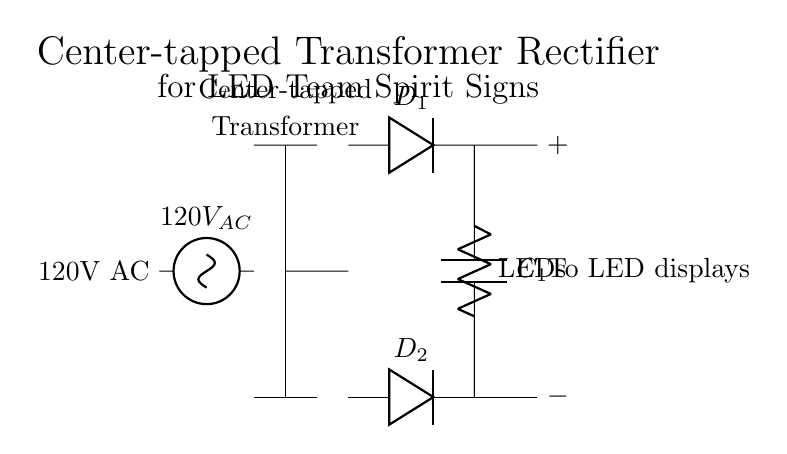What is the input voltage to the circuit? The input voltage to the circuit is labeled as 120V AC, which is a common voltage for household circuits.
Answer: 120V AC What is the purpose of the smoothing capacitor? The smoothing capacitor is used to reduce the ripple in the output voltage, providing a more stable DC voltage to the load.
Answer: Stabilize voltage What are the components used for rectification in this circuit? The components used for rectification are the two diodes labeled D1 and D2 connected to the output of the transformer.
Answer: D1 and D2 How many diodes are used in this rectification circuit? There are two diodes used in this circuit: D1 and D2, which together form a full-wave rectifier by allowing current to pass during both halves of the AC cycle.
Answer: Two What type of transformer is used in this circuit? The transformer used is a center-tapped transformer, which provides two equal voltages for the diodes to rectify the AC input effectively.
Answer: Center-tapped What does the load on the output represent? The load on the output of the circuit represents the LEDs used for the team spirit signs, as indicated by the label "LEDs" connected to the output terminals.
Answer: LEDs Why is a center-tapped transformer advantageous in this configuration? A center-tapped transformer provides a dual output voltage that allows for full-wave rectification; it efficiently uses both halves of the AC waveform, resulting in higher output voltage for the LEDs.
Answer: Higher output voltage 